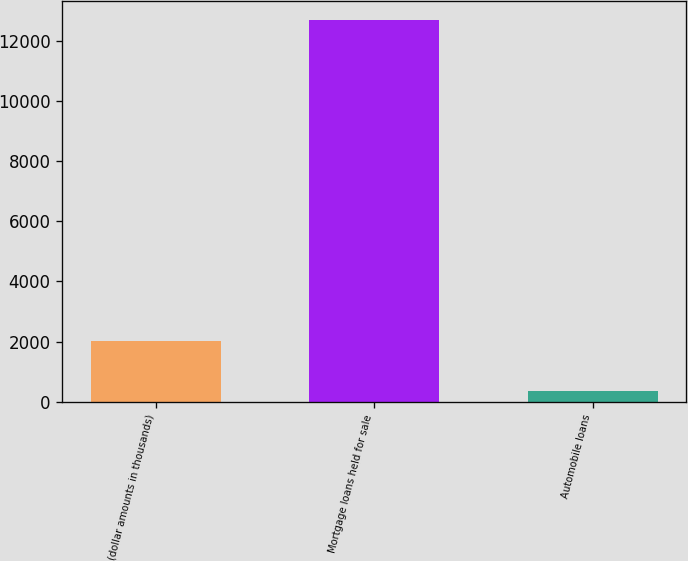Convert chart to OTSL. <chart><loc_0><loc_0><loc_500><loc_500><bar_chart><fcel>(dollar amounts in thousands)<fcel>Mortgage loans held for sale<fcel>Automobile loans<nl><fcel>2013<fcel>12711<fcel>360<nl></chart> 